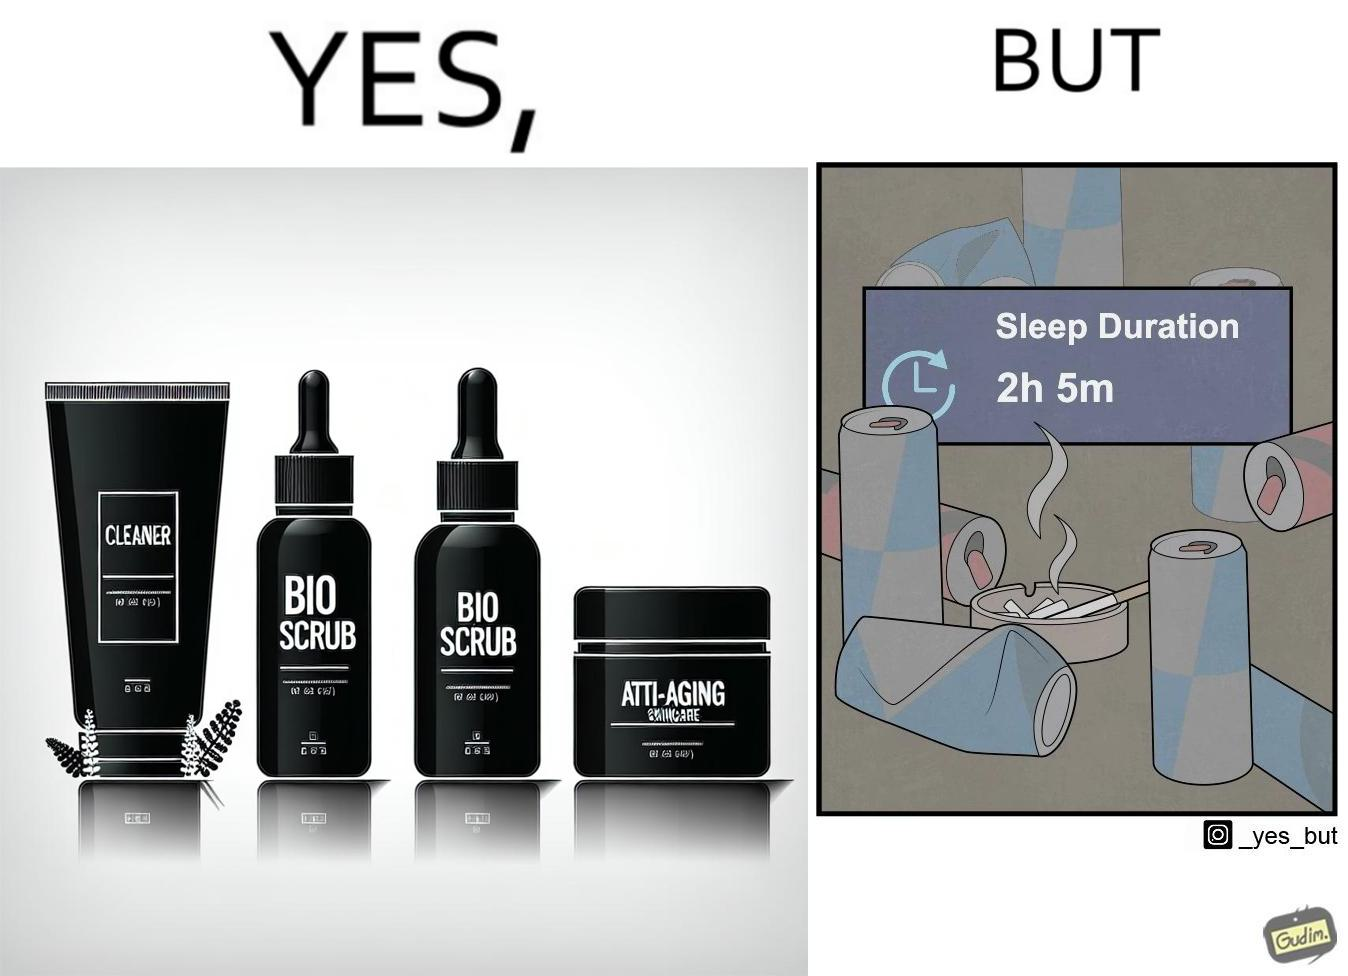Does this image contain satire or humor? Yes, this image is satirical. 